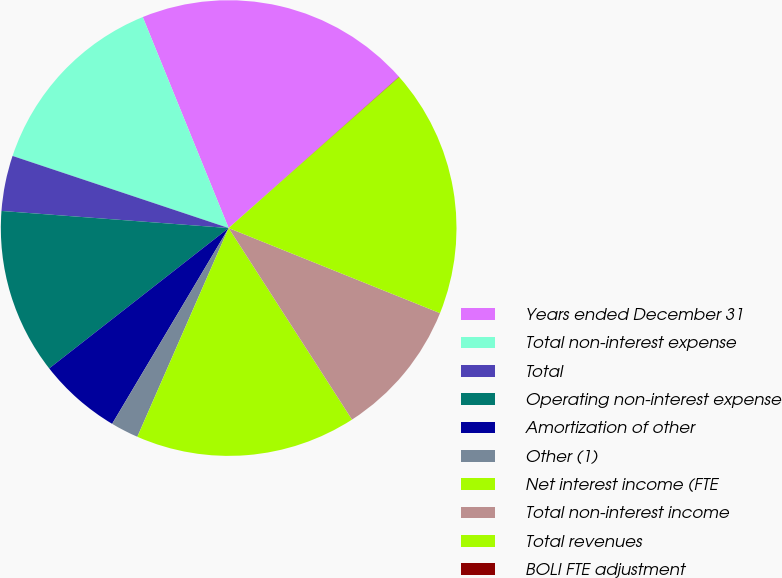<chart> <loc_0><loc_0><loc_500><loc_500><pie_chart><fcel>Years ended December 31<fcel>Total non-interest expense<fcel>Total<fcel>Operating non-interest expense<fcel>Amortization of other<fcel>Other (1)<fcel>Net interest income (FTE<fcel>Total non-interest income<fcel>Total revenues<fcel>BOLI FTE adjustment<nl><fcel>19.59%<fcel>13.72%<fcel>3.93%<fcel>11.76%<fcel>5.89%<fcel>1.98%<fcel>15.67%<fcel>9.8%<fcel>17.63%<fcel>0.02%<nl></chart> 